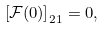Convert formula to latex. <formula><loc_0><loc_0><loc_500><loc_500>\left [ \mathcal { F } ( 0 ) \right ] _ { 2 1 } = 0 ,</formula> 